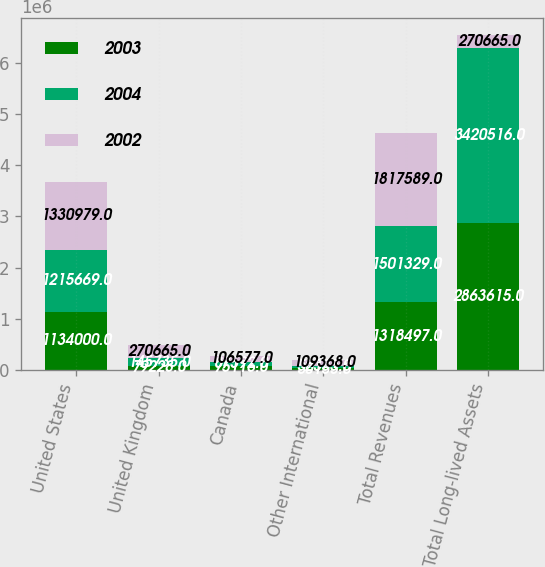Convert chart. <chart><loc_0><loc_0><loc_500><loc_500><stacked_bar_chart><ecel><fcel>United States<fcel>United Kingdom<fcel>Canada<fcel>Other International<fcel>Total Revenues<fcel>Total Long-lived Assets<nl><fcel>2003<fcel>1.134e+06<fcel>79228<fcel>75116<fcel>30153<fcel>1.3185e+06<fcel>2.86362e+06<nl><fcel>2004<fcel>1.21567e+06<fcel>145735<fcel>87592<fcel>52333<fcel>1.50133e+06<fcel>3.42052e+06<nl><fcel>2002<fcel>1.33098e+06<fcel>270665<fcel>106577<fcel>109368<fcel>1.81759e+06<fcel>270665<nl></chart> 